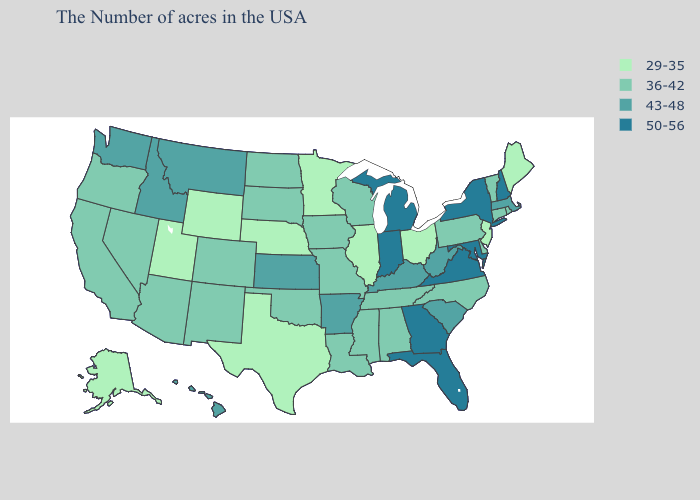What is the value of Florida?
Write a very short answer. 50-56. What is the lowest value in states that border Kentucky?
Answer briefly. 29-35. Among the states that border Texas , which have the lowest value?
Concise answer only. Louisiana, Oklahoma, New Mexico. What is the value of Minnesota?
Concise answer only. 29-35. Does Texas have the lowest value in the South?
Short answer required. Yes. What is the highest value in the Northeast ?
Short answer required. 50-56. What is the value of Montana?
Quick response, please. 43-48. Which states have the lowest value in the USA?
Give a very brief answer. Maine, New Jersey, Ohio, Illinois, Minnesota, Nebraska, Texas, Wyoming, Utah, Alaska. Which states have the lowest value in the USA?
Give a very brief answer. Maine, New Jersey, Ohio, Illinois, Minnesota, Nebraska, Texas, Wyoming, Utah, Alaska. Does the first symbol in the legend represent the smallest category?
Concise answer only. Yes. What is the value of Utah?
Keep it brief. 29-35. Which states have the highest value in the USA?
Quick response, please. New Hampshire, New York, Maryland, Virginia, Florida, Georgia, Michigan, Indiana. Among the states that border Utah , which have the lowest value?
Be succinct. Wyoming. Name the states that have a value in the range 43-48?
Give a very brief answer. Massachusetts, South Carolina, West Virginia, Kentucky, Arkansas, Kansas, Montana, Idaho, Washington, Hawaii. 